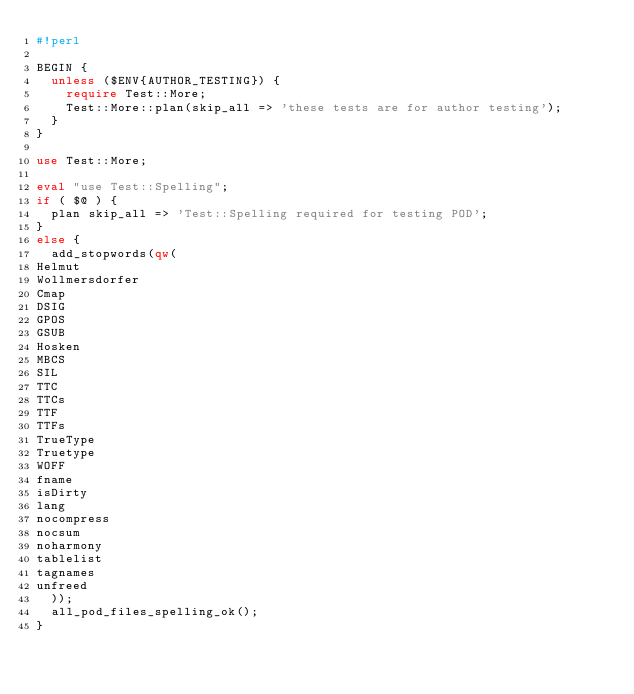Convert code to text. <code><loc_0><loc_0><loc_500><loc_500><_Perl_>#!perl

BEGIN {
  unless ($ENV{AUTHOR_TESTING}) {
    require Test::More;
    Test::More::plan(skip_all => 'these tests are for author testing');
  }
}

use Test::More;

eval "use Test::Spelling";
if ( $@ ) {
  plan skip_all => 'Test::Spelling required for testing POD';
}
else {
  add_stopwords(qw(
Helmut
Wollmersdorfer
Cmap
DSIG
GPOS
GSUB
Hosken
MBCS
SIL
TTC
TTCs
TTF
TTFs
TrueType
Truetype
WOFF
fname
isDirty
lang
nocompress
nocsum
noharmony
tablelist
tagnames
unfreed
  ));
  all_pod_files_spelling_ok();
}


</code> 